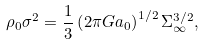<formula> <loc_0><loc_0><loc_500><loc_500>\rho _ { 0 } \sigma ^ { 2 } = \frac { 1 } { 3 } \left ( 2 \pi G a _ { 0 } \right ) ^ { 1 / 2 } \Sigma _ { \infty } ^ { 3 / 2 } ,</formula> 